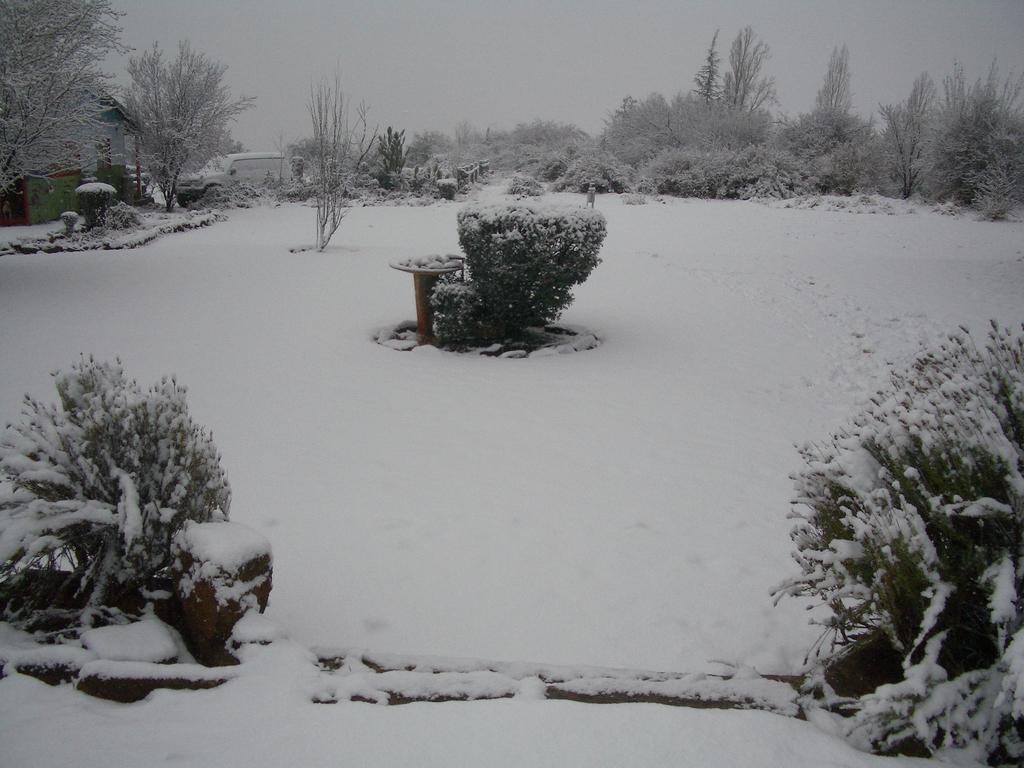What type of vegetation can be seen in the image? There are plants and trees in the image. What is the weather like in the image? There is snow visible in the image, indicating a cold or wintery environment. What type of vehicle is present in the image? There is a vehicle in the image. What is visible in the background of the image? The sky is visible in the image. What type of pancake is being served in the hospital in the image? There is no pancake or hospital present in the image. What type of root can be seen growing near the trees in the image? There is no root visible in the image; only trees and plants are present. 